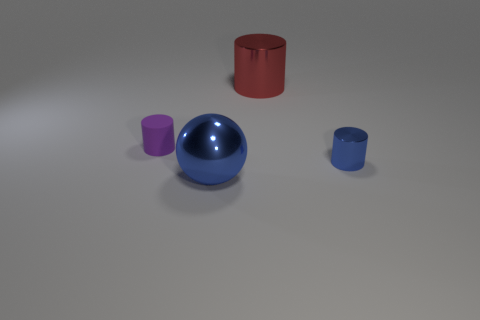Is there anything else that is made of the same material as the tiny purple cylinder?
Offer a very short reply. No. What number of other things are the same color as the ball?
Provide a short and direct response. 1. What shape is the big blue object?
Offer a terse response. Sphere. There is a small cylinder that is in front of the cylinder on the left side of the red thing; what color is it?
Provide a short and direct response. Blue. Do the tiny shiny cylinder and the metal sphere in front of the purple rubber object have the same color?
Your response must be concise. Yes. There is a object that is both right of the big metallic sphere and in front of the red metallic cylinder; what is it made of?
Your answer should be very brief. Metal. Is there a thing of the same size as the red cylinder?
Provide a succinct answer. Yes. What material is the purple object that is the same size as the blue shiny cylinder?
Your answer should be compact. Rubber. What number of big shiny things are behind the blue sphere?
Provide a succinct answer. 1. There is a small object that is on the left side of the red object; is its shape the same as the large blue thing?
Keep it short and to the point. No. 